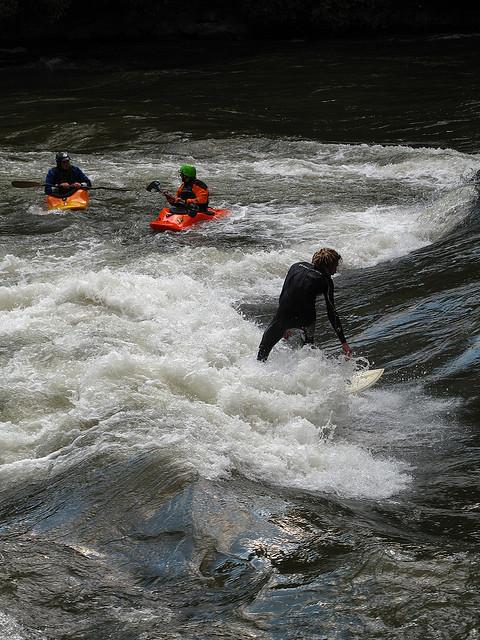What is the person to the far left sitting on? Please explain your reasoning. boat. The people on the left are inside of a raft floating. 